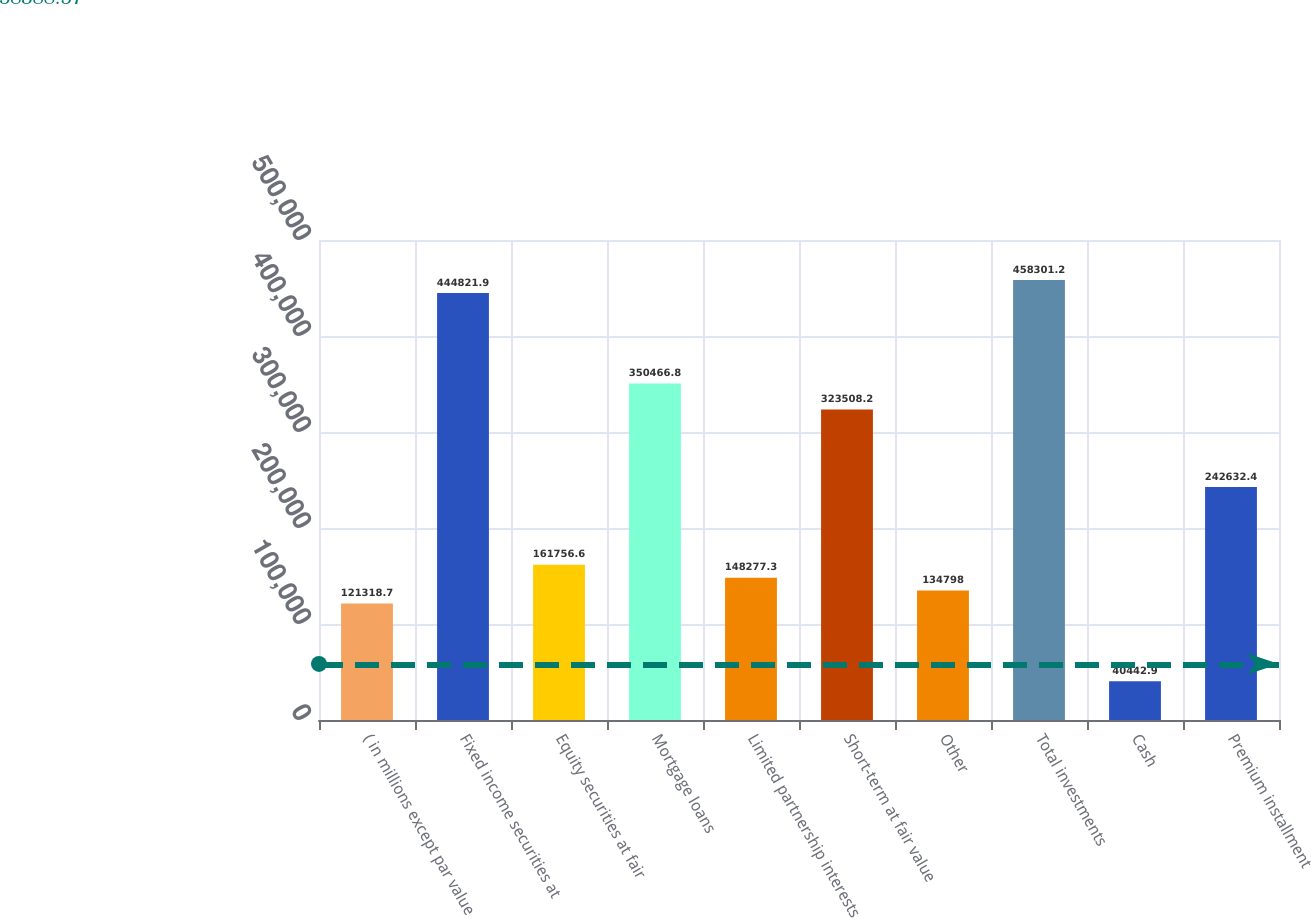<chart> <loc_0><loc_0><loc_500><loc_500><bar_chart><fcel>( in millions except par value<fcel>Fixed income securities at<fcel>Equity securities at fair<fcel>Mortgage loans<fcel>Limited partnership interests<fcel>Short-term at fair value<fcel>Other<fcel>Total investments<fcel>Cash<fcel>Premium installment<nl><fcel>121319<fcel>444822<fcel>161757<fcel>350467<fcel>148277<fcel>323508<fcel>134798<fcel>458301<fcel>40442.9<fcel>242632<nl></chart> 